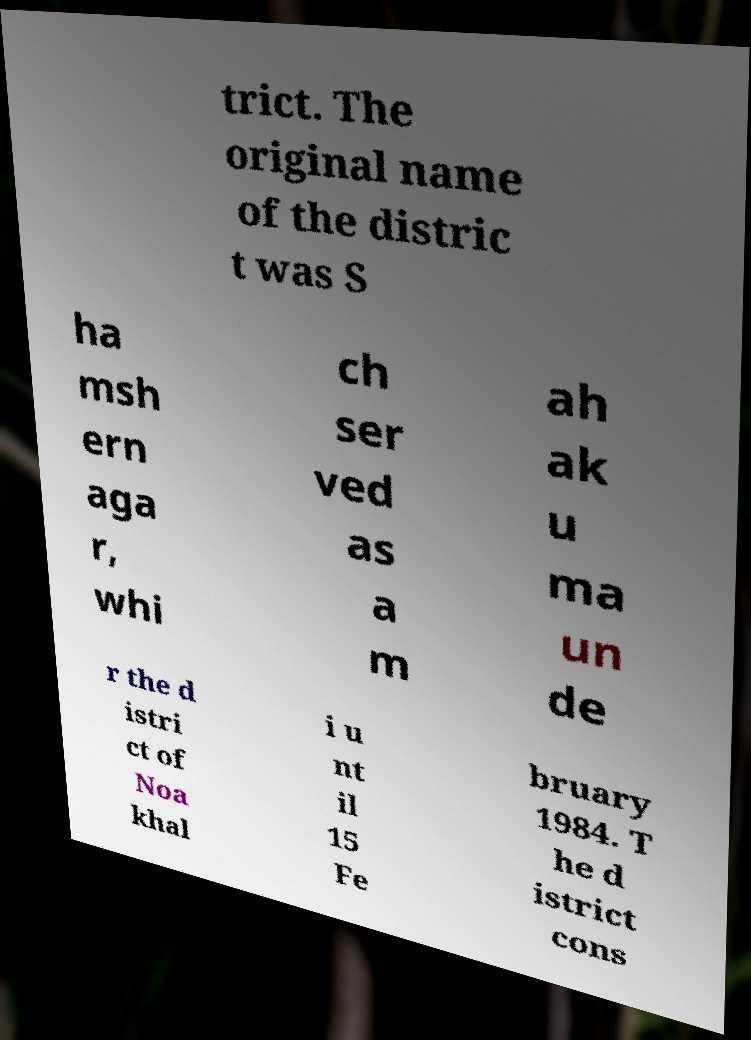Can you read and provide the text displayed in the image?This photo seems to have some interesting text. Can you extract and type it out for me? trict. The original name of the distric t was S ha msh ern aga r, whi ch ser ved as a m ah ak u ma un de r the d istri ct of Noa khal i u nt il 15 Fe bruary 1984. T he d istrict cons 